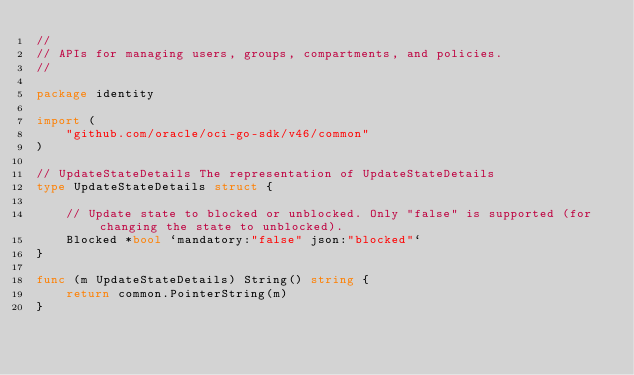Convert code to text. <code><loc_0><loc_0><loc_500><loc_500><_Go_>//
// APIs for managing users, groups, compartments, and policies.
//

package identity

import (
	"github.com/oracle/oci-go-sdk/v46/common"
)

// UpdateStateDetails The representation of UpdateStateDetails
type UpdateStateDetails struct {

	// Update state to blocked or unblocked. Only "false" is supported (for changing the state to unblocked).
	Blocked *bool `mandatory:"false" json:"blocked"`
}

func (m UpdateStateDetails) String() string {
	return common.PointerString(m)
}
</code> 